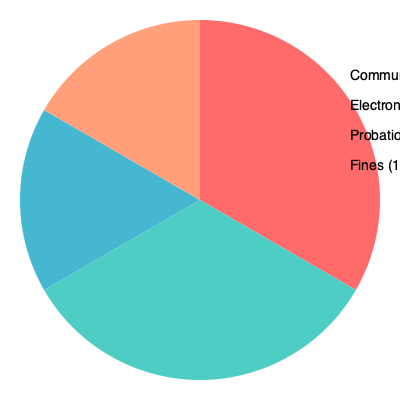Based on the pie chart showing the distribution of alternative sentencing methods in the Netherlands, which method is most frequently used and what percentage does it represent? To answer this question, we need to analyze the pie chart representing the distribution of alternative sentencing methods in the Netherlands. The chart is divided into four sections, each representing a different sentencing method:

1. The largest section, colored in red, represents Community Service at 40%.
2. The second largest section, in teal, shows Electronic Monitoring at 30%.
3. The blue section indicates Probation at 20%.
4. The smallest section, in light orange, represents Fines at 10%.

By comparing the sizes of these sections, we can determine that the largest section corresponds to the most frequently used method. In this case, it is Community Service, which accounts for 40% of alternative sentencing methods in the Netherlands.
Answer: Community Service, 40% 